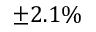<formula> <loc_0><loc_0><loc_500><loc_500>\pm 2 . 1 \%</formula> 